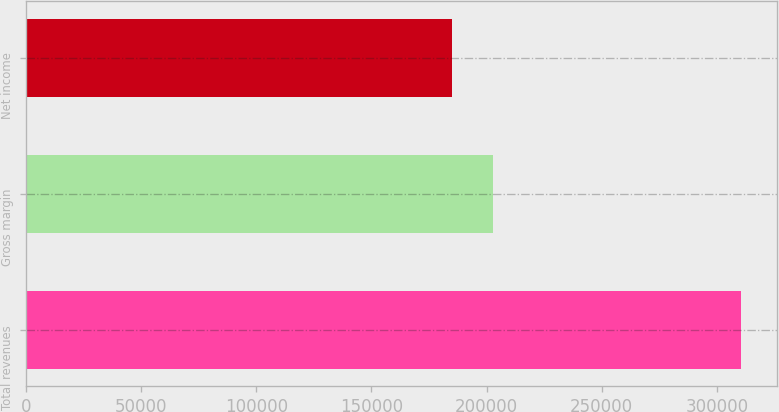Convert chart to OTSL. <chart><loc_0><loc_0><loc_500><loc_500><bar_chart><fcel>Total revenues<fcel>Gross margin<fcel>Net income<nl><fcel>310558<fcel>202788<fcel>185027<nl></chart> 